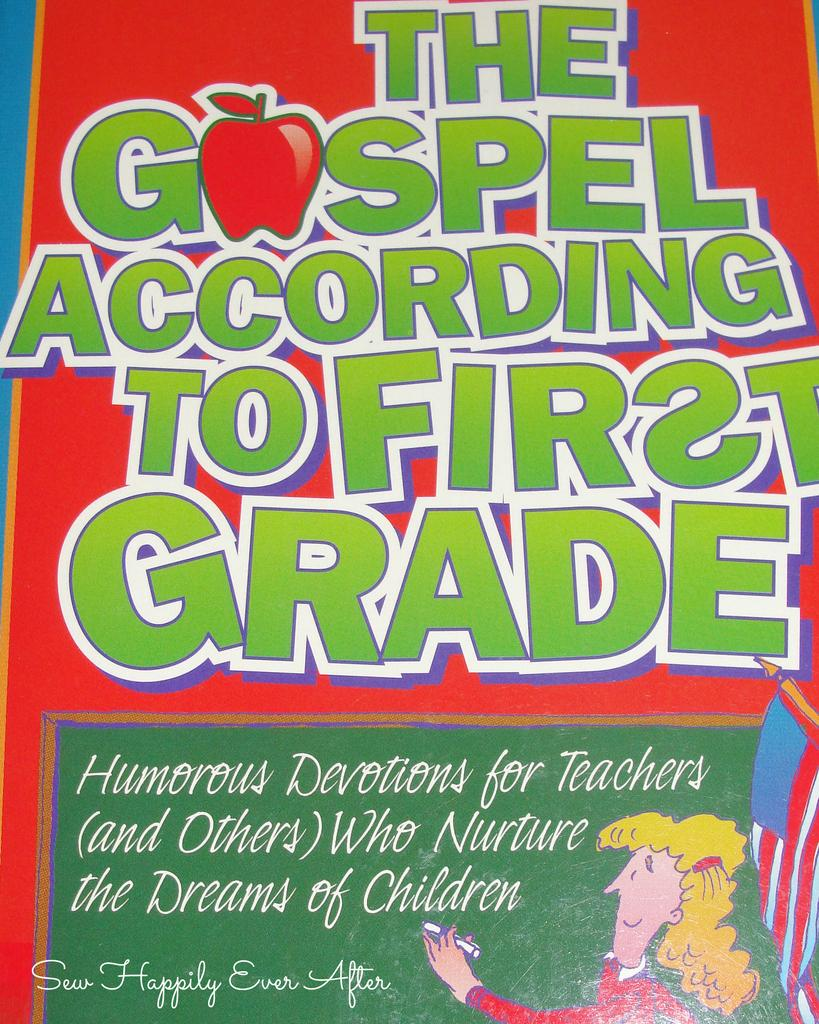What is the main subject of the image? The main subject of the image is a cover page of a book. What can be seen on the cover page? There is writing on the cover page. What else is depicted in the image? There is an image of a girl in the image. What is the girl doing in the image? The girl is writing something on a board. Can you tell me how many kites the girl is holding in the image? There are no kites present in the image; the girl is writing on a board. What type of mouth does the girl have in the image? There is no specific detail about the girl's mouth in the image, as the focus is on her writing on a board. 